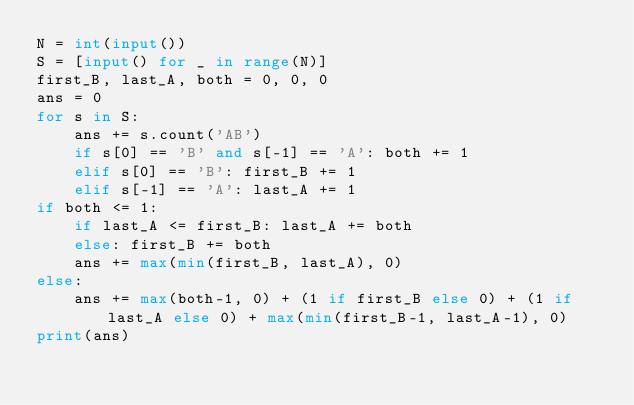Convert code to text. <code><loc_0><loc_0><loc_500><loc_500><_Python_>N = int(input())
S = [input() for _ in range(N)]
first_B, last_A, both = 0, 0, 0
ans = 0
for s in S:
    ans += s.count('AB')
    if s[0] == 'B' and s[-1] == 'A': both += 1
    elif s[0] == 'B': first_B += 1
    elif s[-1] == 'A': last_A += 1
if both <= 1:
    if last_A <= first_B: last_A += both
    else: first_B += both
    ans += max(min(first_B, last_A), 0)
else:
    ans += max(both-1, 0) + (1 if first_B else 0) + (1 if last_A else 0) + max(min(first_B-1, last_A-1), 0)
print(ans)</code> 